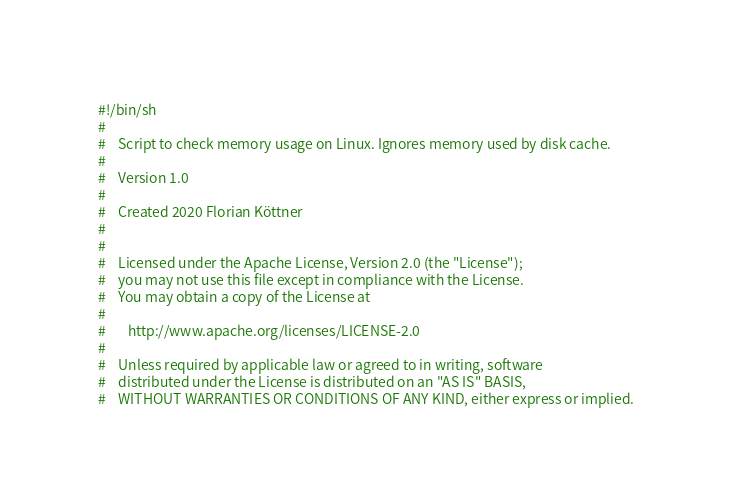Convert code to text. <code><loc_0><loc_0><loc_500><loc_500><_Bash_>#!/bin/sh
#
#    Script to check memory usage on Linux. Ignores memory used by disk cache.
#
#    Version 1.0
#
#    Created 2020 Florian Köttner
#
#
#    Licensed under the Apache License, Version 2.0 (the "License");
#    you may not use this file except in compliance with the License.
#    You may obtain a copy of the License at
#
#       http://www.apache.org/licenses/LICENSE-2.0
#
#    Unless required by applicable law or agreed to in writing, software
#    distributed under the License is distributed on an "AS IS" BASIS,
#    WITHOUT WARRANTIES OR CONDITIONS OF ANY KIND, either express or implied.</code> 